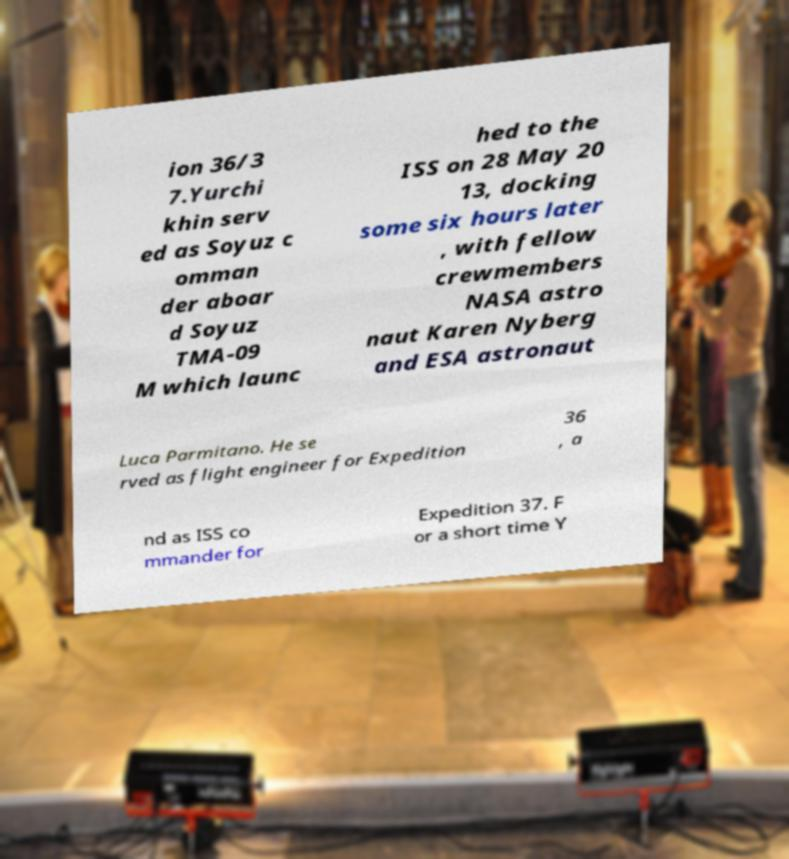For documentation purposes, I need the text within this image transcribed. Could you provide that? ion 36/3 7.Yurchi khin serv ed as Soyuz c omman der aboar d Soyuz TMA-09 M which launc hed to the ISS on 28 May 20 13, docking some six hours later , with fellow crewmembers NASA astro naut Karen Nyberg and ESA astronaut Luca Parmitano. He se rved as flight engineer for Expedition 36 , a nd as ISS co mmander for Expedition 37. F or a short time Y 